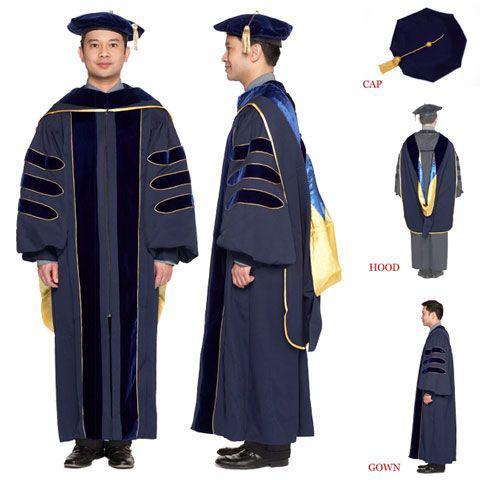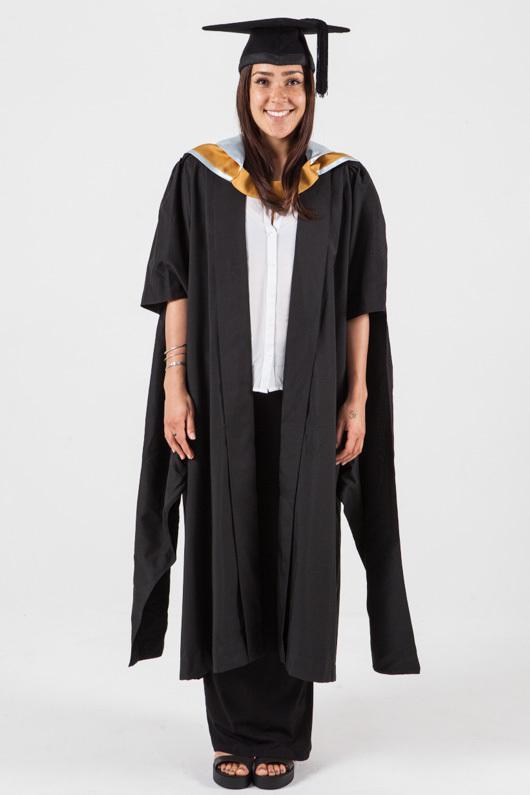The first image is the image on the left, the second image is the image on the right. Assess this claim about the two images: "All graduation gown models are one gender.". Correct or not? Answer yes or no. No. The first image is the image on the left, the second image is the image on the right. Evaluate the accuracy of this statement regarding the images: "At least one image shows only a female graduate.". Is it true? Answer yes or no. Yes. 